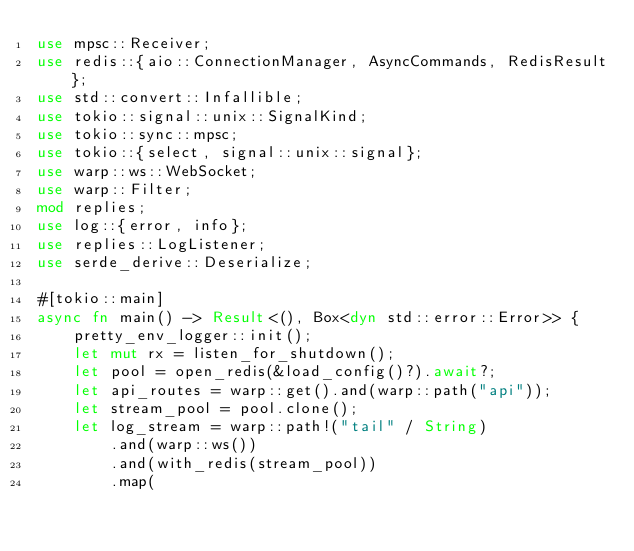<code> <loc_0><loc_0><loc_500><loc_500><_Rust_>use mpsc::Receiver;
use redis::{aio::ConnectionManager, AsyncCommands, RedisResult};
use std::convert::Infallible;
use tokio::signal::unix::SignalKind;
use tokio::sync::mpsc;
use tokio::{select, signal::unix::signal};
use warp::ws::WebSocket;
use warp::Filter;
mod replies;
use log::{error, info};
use replies::LogListener;
use serde_derive::Deserialize;

#[tokio::main]
async fn main() -> Result<(), Box<dyn std::error::Error>> {
    pretty_env_logger::init();
    let mut rx = listen_for_shutdown();
    let pool = open_redis(&load_config()?).await?;
    let api_routes = warp::get().and(warp::path("api"));
    let stream_pool = pool.clone();
    let log_stream = warp::path!("tail" / String)
        .and(warp::ws())
        .and(with_redis(stream_pool))
        .map(</code> 